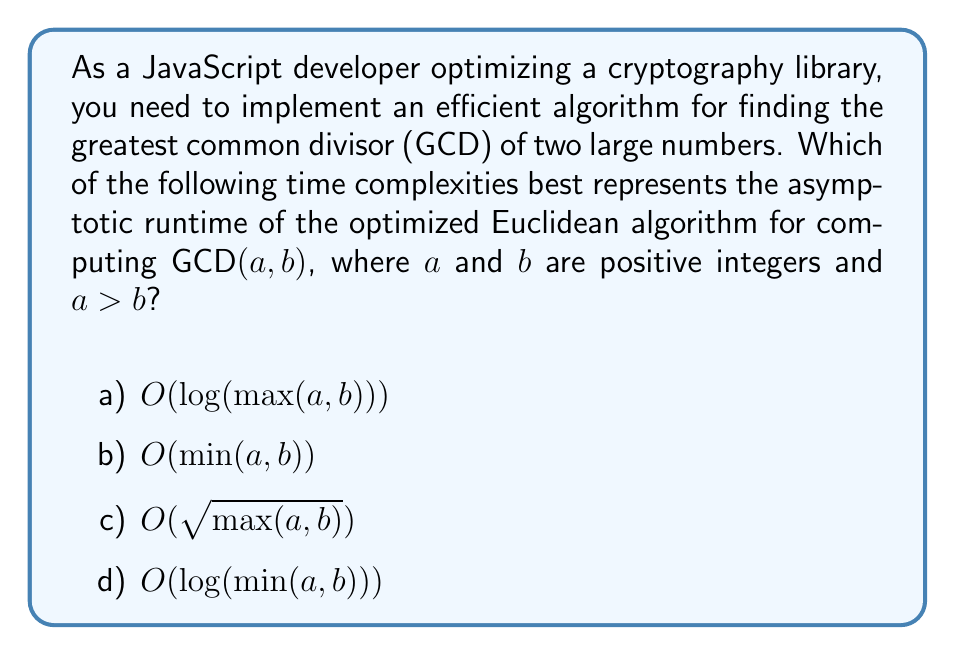Solve this math problem. Let's analyze the optimized Euclidean algorithm for finding the GCD:

1. The Euclidean algorithm is based on the principle that the greatest common divisor of two numbers doesn't change if the smaller number is subtracted from the larger number.

2. The optimized version uses the modulo operation instead of subtraction:

   $$\text{GCD}(a, b) = \text{GCD}(b, a \bmod b)$$

3. This process continues recursively until $b$ becomes 0, at which point $a$ is the GCD.

4. The number of steps in this algorithm is related to the number of digits in the input, not the magnitude of the numbers themselves.

5. It can be proven that the number of steps is proportional to the logarithm of the larger number.

6. Specifically, the worst-case number of steps is proportional to the number of digits in the larger number in base 2, which is $\log_2(\max(a, b))$.

7. Therefore, the time complexity of the optimized Euclidean algorithm is $O(\log(\max(a, b)))$.

This logarithmic time complexity makes the algorithm highly efficient, even for very large numbers, which is crucial for cryptographic applications in JavaScript.
Answer: a) $O(\log(\max(a, b)))$ 